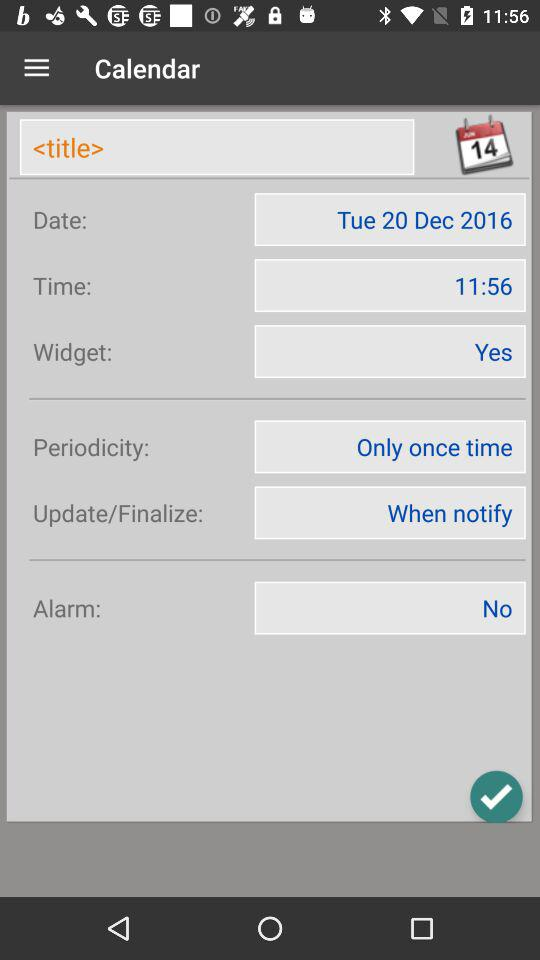What's the setting for the update? The setting for the update is "When notify". 